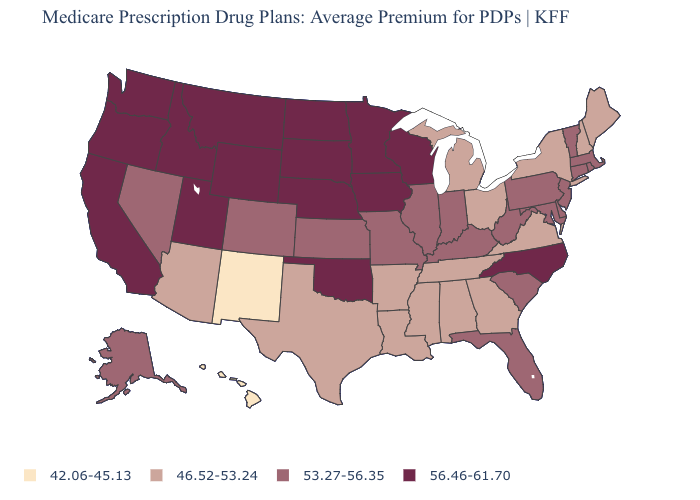Is the legend a continuous bar?
Write a very short answer. No. What is the value of Connecticut?
Keep it brief. 53.27-56.35. What is the highest value in states that border New Hampshire?
Keep it brief. 53.27-56.35. What is the value of Kentucky?
Give a very brief answer. 53.27-56.35. What is the value of Oklahoma?
Write a very short answer. 56.46-61.70. Does Maine have a lower value than Louisiana?
Quick response, please. No. Name the states that have a value in the range 46.52-53.24?
Concise answer only. Alabama, Arkansas, Arizona, Georgia, Louisiana, Maine, Michigan, Mississippi, New Hampshire, New York, Ohio, Tennessee, Texas, Virginia. What is the value of North Dakota?
Give a very brief answer. 56.46-61.70. What is the value of North Carolina?
Concise answer only. 56.46-61.70. Does the first symbol in the legend represent the smallest category?
Keep it brief. Yes. Name the states that have a value in the range 42.06-45.13?
Short answer required. Hawaii, New Mexico. Which states hav the highest value in the West?
Answer briefly. California, Idaho, Montana, Oregon, Utah, Washington, Wyoming. Which states have the lowest value in the USA?
Short answer required. Hawaii, New Mexico. Does Ohio have the highest value in the USA?
Write a very short answer. No. Name the states that have a value in the range 56.46-61.70?
Short answer required. California, Iowa, Idaho, Minnesota, Montana, North Carolina, North Dakota, Nebraska, Oklahoma, Oregon, South Dakota, Utah, Washington, Wisconsin, Wyoming. 